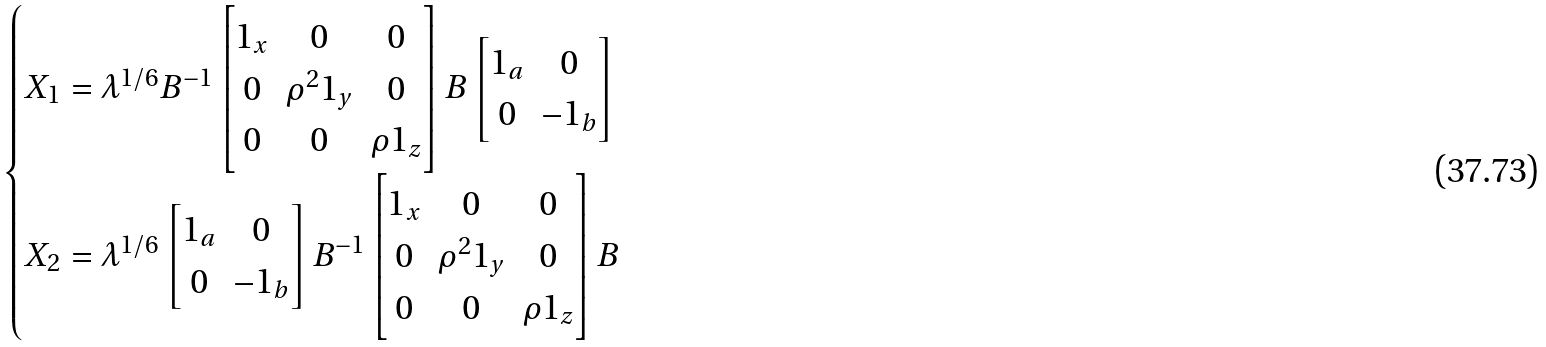Convert formula to latex. <formula><loc_0><loc_0><loc_500><loc_500>\begin{cases} X _ { 1 } = \lambda ^ { 1 / 6 } B ^ { - 1 } \begin{bmatrix} 1 _ { x } & 0 & 0 \\ 0 & \rho ^ { 2 } 1 _ { y } & 0 \\ 0 & 0 & \rho 1 _ { z } \end{bmatrix} B \begin{bmatrix} 1 _ { a } & 0 \\ 0 & - 1 _ { b } \end{bmatrix} \\ X _ { 2 } = \lambda ^ { 1 / 6 } \begin{bmatrix} 1 _ { a } & 0 \\ 0 & - 1 _ { b } \end{bmatrix} B ^ { - 1 } \begin{bmatrix} 1 _ { x } & 0 & 0 \\ 0 & \rho ^ { 2 } 1 _ { y } & 0 \\ 0 & 0 & \rho 1 _ { z } \end{bmatrix} B \end{cases}</formula> 